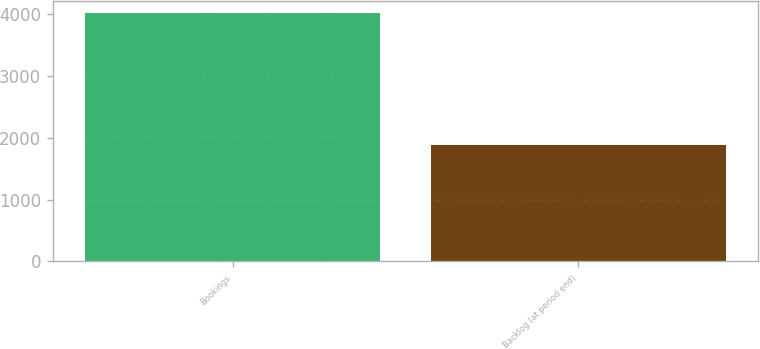<chart> <loc_0><loc_0><loc_500><loc_500><bar_chart><fcel>Bookings<fcel>Backlog (at period end)<nl><fcel>4019.8<fcel>1891.6<nl></chart> 